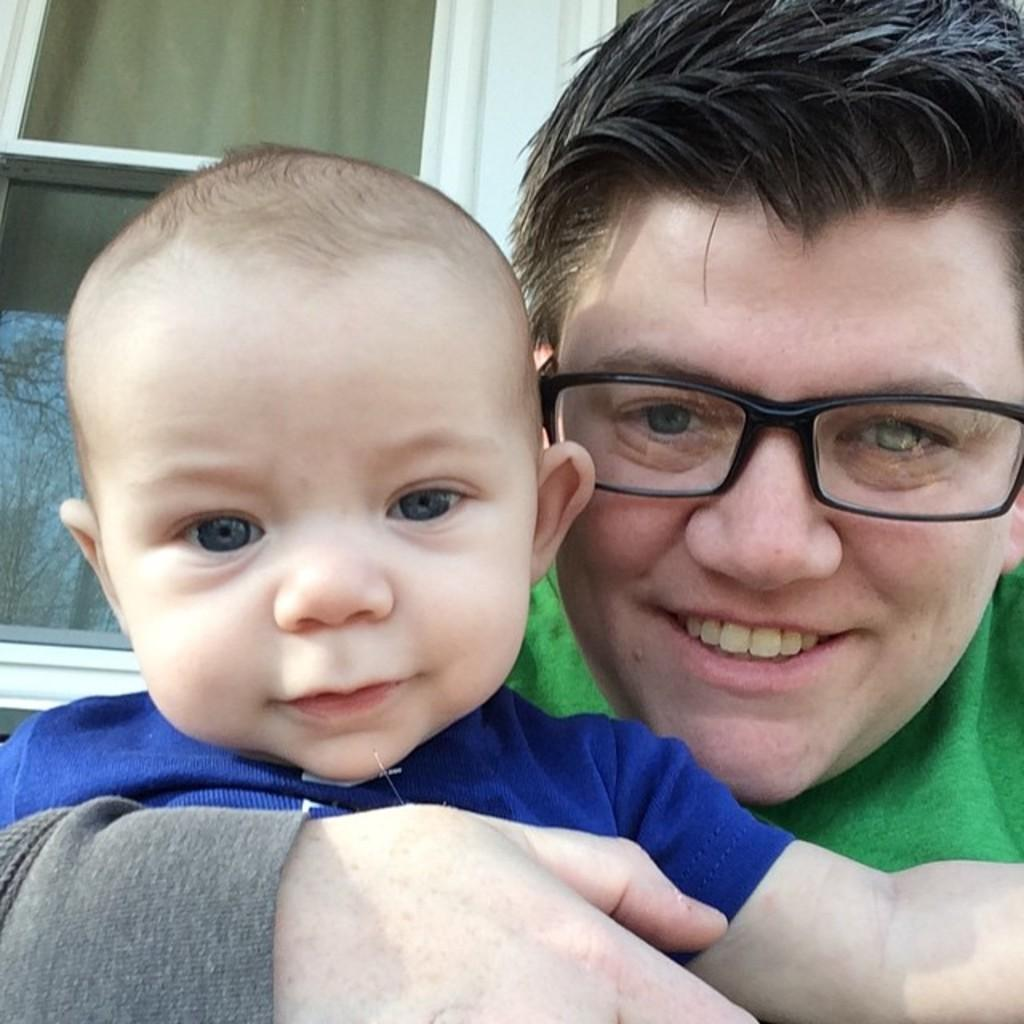Who or what can be seen in the image? There are people in the image. What is the color of the window in the background? The window in the background is white-colored. What can be seen in the reflection of the window? The reflection of trees is visible in the mirror of the window. What language are the giants speaking in the image? There are no giants present in the image, and therefore no language can be attributed to them. How much sand is visible in the image? There is no sand visible in the image. 